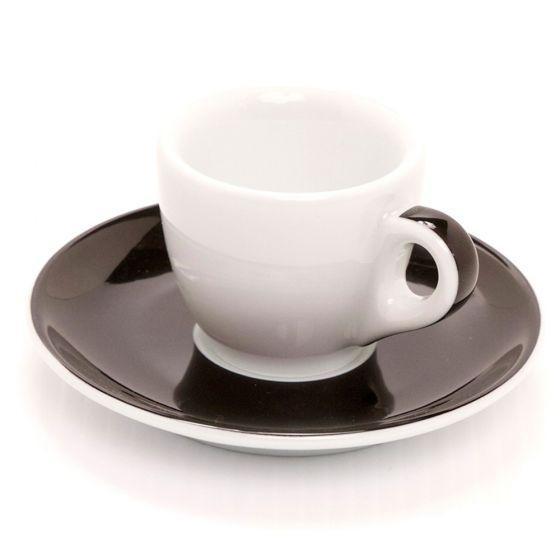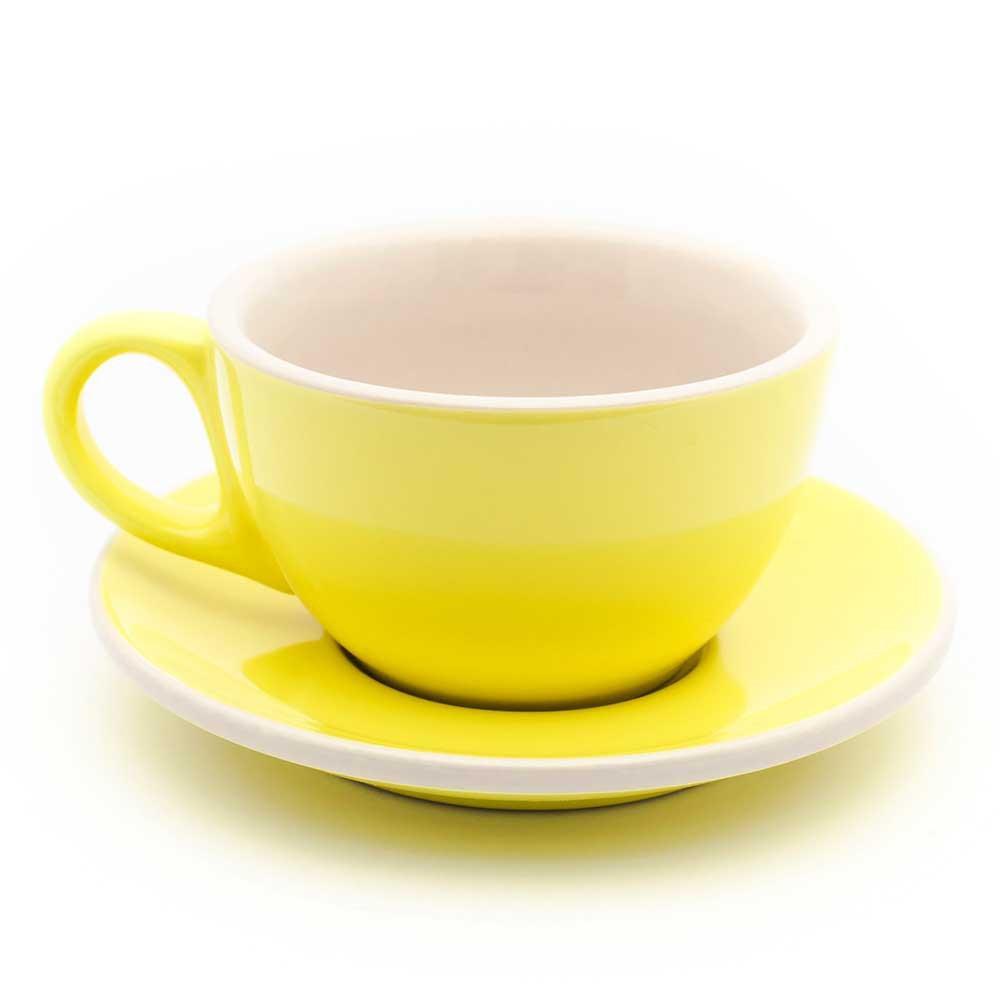The first image is the image on the left, the second image is the image on the right. For the images displayed, is the sentence "The left and right image contains a total of three full coffee cups." factually correct? Answer yes or no. No. The first image is the image on the left, the second image is the image on the right. Considering the images on both sides, is "There is a milk design in a coffee." valid? Answer yes or no. No. 